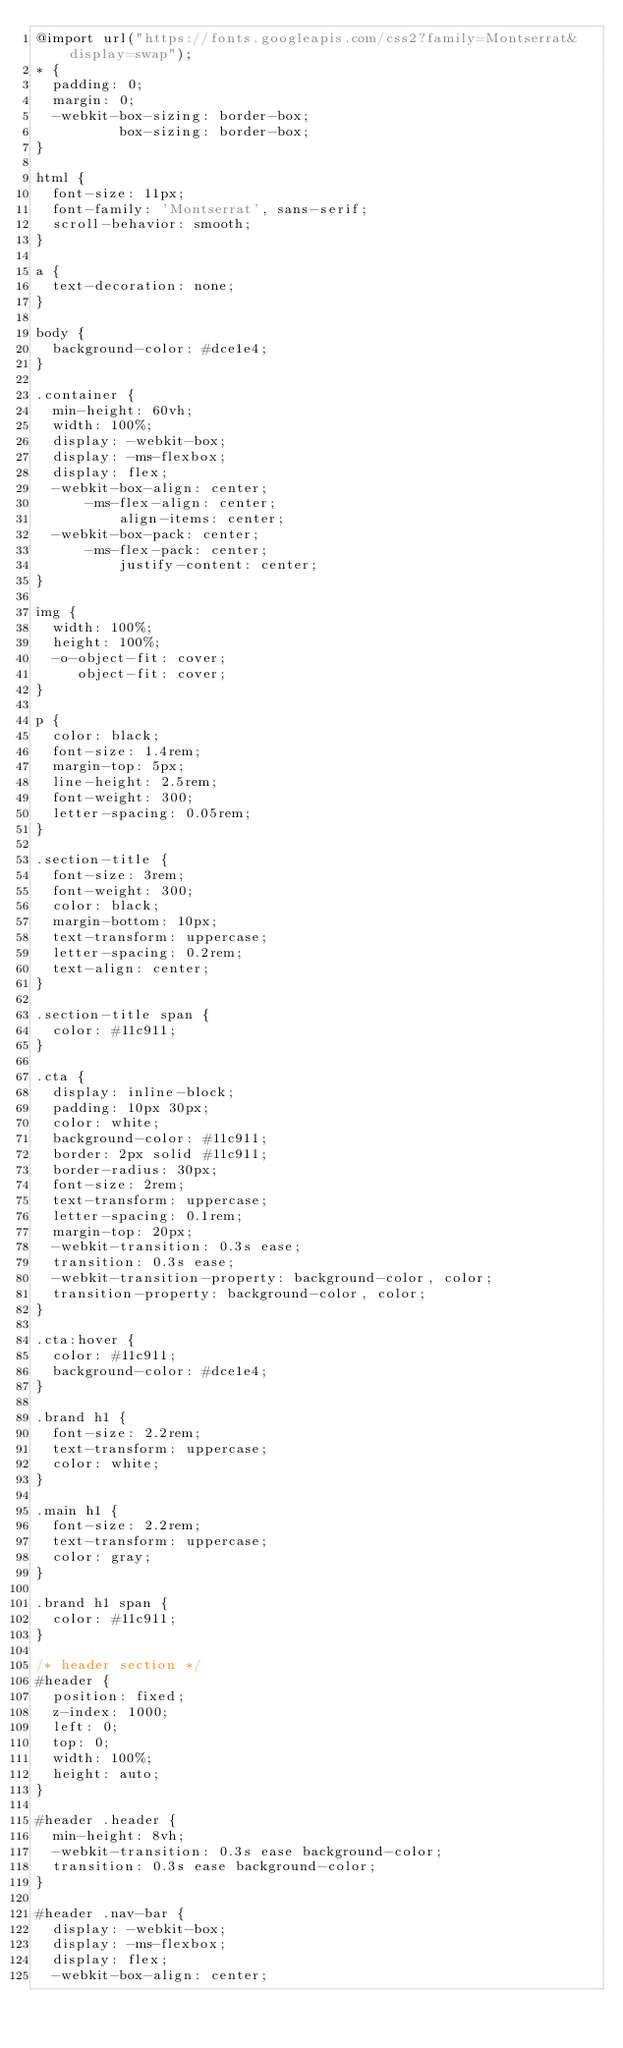Convert code to text. <code><loc_0><loc_0><loc_500><loc_500><_CSS_>@import url("https://fonts.googleapis.com/css2?family=Montserrat&display=swap");
* {
  padding: 0;
  margin: 0;
  -webkit-box-sizing: border-box;
          box-sizing: border-box;
}

html {
  font-size: 11px;
  font-family: 'Montserrat', sans-serif;
  scroll-behavior: smooth;
}

a {
  text-decoration: none;
}

body {
  background-color: #dce1e4;
}

.container {
  min-height: 60vh;
  width: 100%;
  display: -webkit-box;
  display: -ms-flexbox;
  display: flex;
  -webkit-box-align: center;
      -ms-flex-align: center;
          align-items: center;
  -webkit-box-pack: center;
      -ms-flex-pack: center;
          justify-content: center;
}

img {
  width: 100%;
  height: 100%;
  -o-object-fit: cover;
     object-fit: cover;
}

p {
  color: black;
  font-size: 1.4rem;
  margin-top: 5px;
  line-height: 2.5rem;
  font-weight: 300;
  letter-spacing: 0.05rem;
}

.section-title {
  font-size: 3rem;
  font-weight: 300;
  color: black;
  margin-bottom: 10px;
  text-transform: uppercase;
  letter-spacing: 0.2rem;
  text-align: center;
}

.section-title span {
  color: #11c911;
}

.cta {
  display: inline-block;
  padding: 10px 30px;
  color: white;
  background-color: #11c911;
  border: 2px solid #11c911;
  border-radius: 30px;
  font-size: 2rem;
  text-transform: uppercase;
  letter-spacing: 0.1rem;
  margin-top: 20px;
  -webkit-transition: 0.3s ease;
  transition: 0.3s ease;
  -webkit-transition-property: background-color, color;
  transition-property: background-color, color;
}

.cta:hover {
  color: #11c911;
  background-color: #dce1e4;
}

.brand h1 {
  font-size: 2.2rem;
  text-transform: uppercase;
  color: white;
}

.main h1 {
  font-size: 2.2rem;
  text-transform: uppercase;
  color: gray;
}

.brand h1 span {
  color: #11c911;
}

/* header section */
#header {
  position: fixed;
  z-index: 1000;
  left: 0;
  top: 0;
  width: 100%;
  height: auto;
}

#header .header {
  min-height: 8vh;
  -webkit-transition: 0.3s ease background-color;
  transition: 0.3s ease background-color;
}

#header .nav-bar {
  display: -webkit-box;
  display: -ms-flexbox;
  display: flex;
  -webkit-box-align: center;</code> 